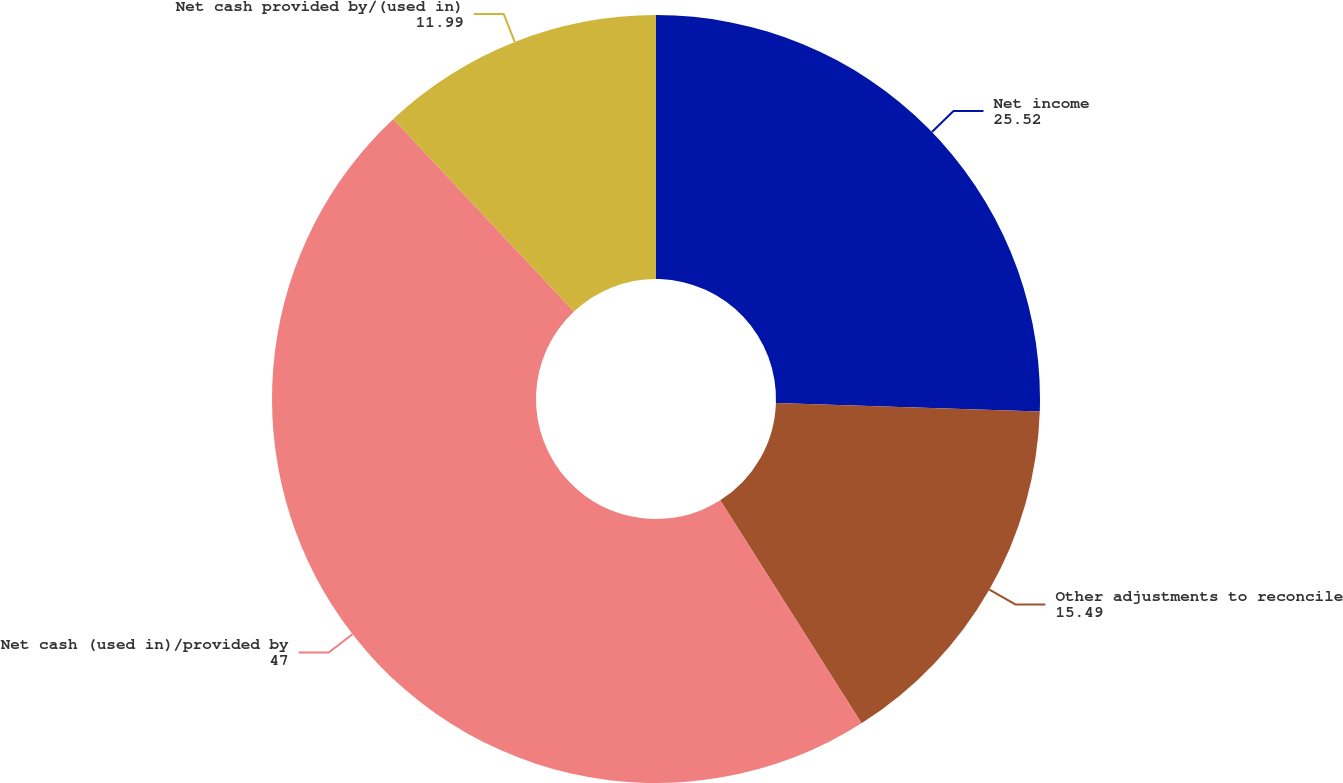<chart> <loc_0><loc_0><loc_500><loc_500><pie_chart><fcel>Net income<fcel>Other adjustments to reconcile<fcel>Net cash (used in)/provided by<fcel>Net cash provided by/(used in)<nl><fcel>25.52%<fcel>15.49%<fcel>47.0%<fcel>11.99%<nl></chart> 